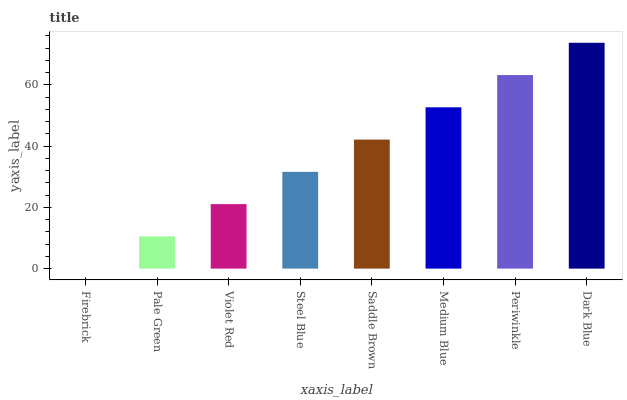Is Firebrick the minimum?
Answer yes or no. Yes. Is Dark Blue the maximum?
Answer yes or no. Yes. Is Pale Green the minimum?
Answer yes or no. No. Is Pale Green the maximum?
Answer yes or no. No. Is Pale Green greater than Firebrick?
Answer yes or no. Yes. Is Firebrick less than Pale Green?
Answer yes or no. Yes. Is Firebrick greater than Pale Green?
Answer yes or no. No. Is Pale Green less than Firebrick?
Answer yes or no. No. Is Saddle Brown the high median?
Answer yes or no. Yes. Is Steel Blue the low median?
Answer yes or no. Yes. Is Pale Green the high median?
Answer yes or no. No. Is Firebrick the low median?
Answer yes or no. No. 